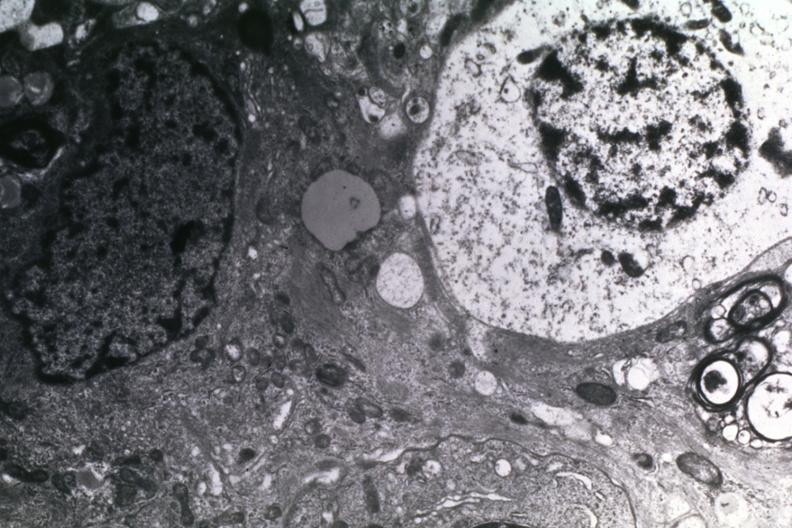does size show dr garcia tumors 14?
Answer the question using a single word or phrase. No 